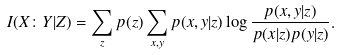Convert formula to latex. <formula><loc_0><loc_0><loc_500><loc_500>I ( X \colon Y | Z ) = \sum _ { z } p ( z ) \sum _ { x , y } p ( x , y | z ) \log \frac { p ( x , y | z ) } { p ( x | z ) p ( y | z ) } .</formula> 